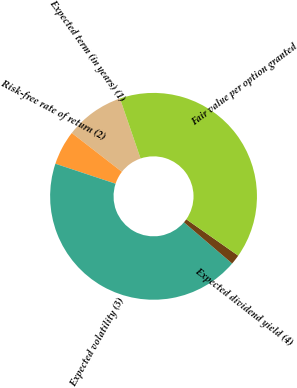Convert chart. <chart><loc_0><loc_0><loc_500><loc_500><pie_chart><fcel>Expected term (in years) (1)<fcel>Risk-free rate of return (2)<fcel>Expected volatility (3)<fcel>Expected dividend yield (4)<fcel>Fair value per option granted<nl><fcel>9.25%<fcel>5.39%<fcel>43.84%<fcel>1.53%<fcel>39.98%<nl></chart> 